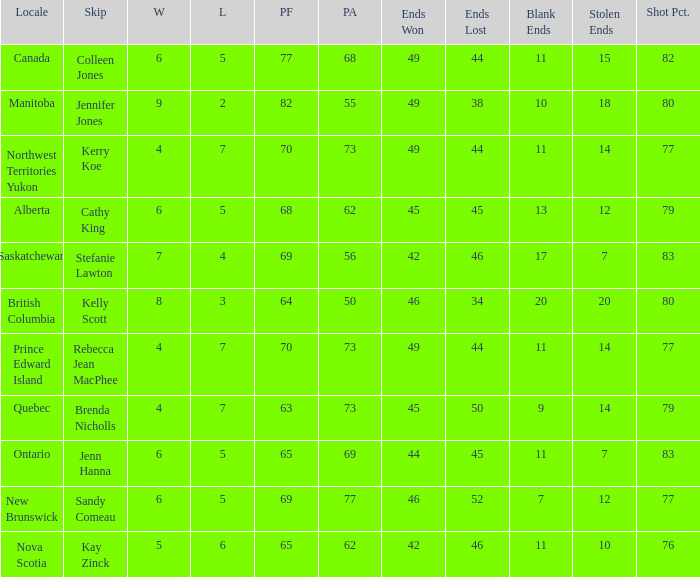What is the lowest PF? 63.0. 